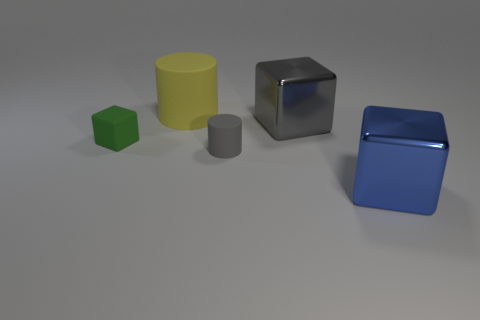How many tiny green cubes are on the left side of the large blue shiny thing in front of the big rubber thing?
Ensure brevity in your answer.  1. Is the number of large shiny objects to the left of the green matte thing greater than the number of big blue shiny objects left of the tiny cylinder?
Offer a terse response. No. What is the tiny green block made of?
Give a very brief answer. Rubber. Is there a green thing that has the same size as the yellow matte cylinder?
Keep it short and to the point. No. There is a yellow cylinder that is the same size as the gray block; what material is it?
Offer a very short reply. Rubber. How many green shiny objects are there?
Offer a terse response. 0. There is a metallic thing behind the large blue block; what is its size?
Keep it short and to the point. Large. Are there the same number of metal objects on the right side of the yellow rubber thing and tiny cyan cubes?
Give a very brief answer. No. Is there a big purple thing that has the same shape as the large gray thing?
Make the answer very short. No. What is the shape of the thing that is both in front of the green matte object and behind the blue block?
Keep it short and to the point. Cylinder. 